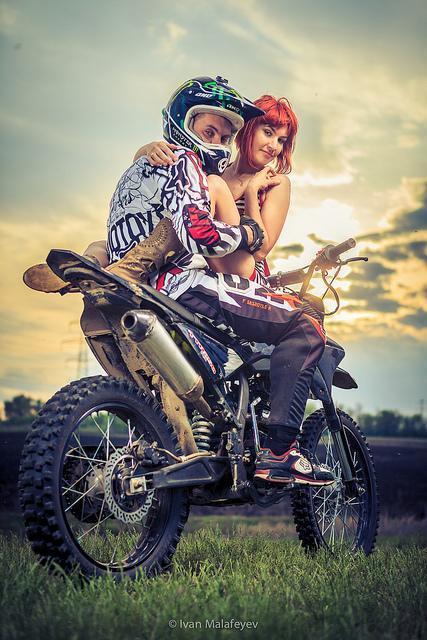How many people are shown?
Give a very brief answer. 2. How many people are visible?
Give a very brief answer. 2. 